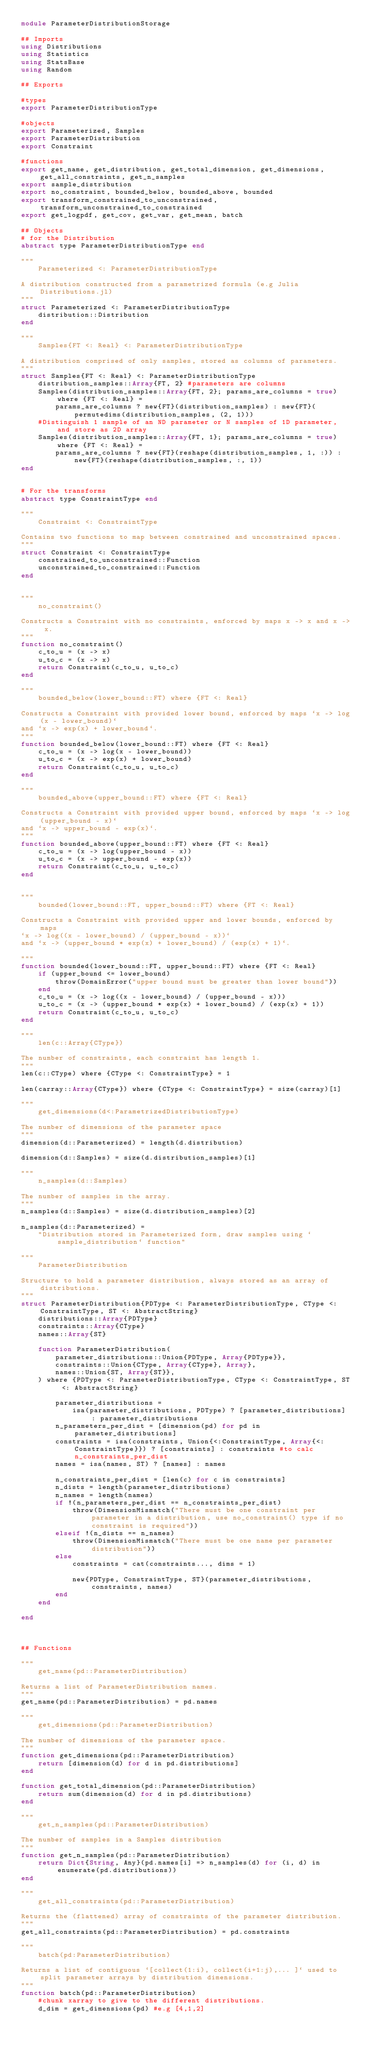Convert code to text. <code><loc_0><loc_0><loc_500><loc_500><_Julia_>module ParameterDistributionStorage

## Imports
using Distributions
using Statistics
using StatsBase
using Random

## Exports

#types
export ParameterDistributionType

#objects
export Parameterized, Samples
export ParameterDistribution
export Constraint

#functions
export get_name, get_distribution, get_total_dimension, get_dimensions, get_all_constraints, get_n_samples
export sample_distribution
export no_constraint, bounded_below, bounded_above, bounded
export transform_constrained_to_unconstrained, transform_unconstrained_to_constrained
export get_logpdf, get_cov, get_var, get_mean, batch

## Objects
# for the Distribution
abstract type ParameterDistributionType end

"""
    Parameterized <: ParameterDistributionType
    
A distribution constructed from a parametrized formula (e.g Julia Distributions.jl)
"""
struct Parameterized <: ParameterDistributionType
    distribution::Distribution
end

"""
    Samples{FT <: Real} <: ParameterDistributionType

A distribution comprised of only samples, stored as columns of parameters.
"""
struct Samples{FT <: Real} <: ParameterDistributionType
    distribution_samples::Array{FT, 2} #parameters are columns
    Samples(distribution_samples::Array{FT, 2}; params_are_columns = true) where {FT <: Real} =
        params_are_columns ? new{FT}(distribution_samples) : new{FT}(permutedims(distribution_samples, (2, 1)))
    #Distinguish 1 sample of an ND parameter or N samples of 1D parameter, and store as 2D array  
    Samples(distribution_samples::Array{FT, 1}; params_are_columns = true) where {FT <: Real} =
        params_are_columns ? new{FT}(reshape(distribution_samples, 1, :)) : new{FT}(reshape(distribution_samples, :, 1))
end


# For the transforms
abstract type ConstraintType end

"""
    Constraint <: ConstraintType

Contains two functions to map between constrained and unconstrained spaces.
"""
struct Constraint <: ConstraintType
    constrained_to_unconstrained::Function
    unconstrained_to_constrained::Function
end


"""
    no_constraint()

Constructs a Constraint with no constraints, enforced by maps x -> x and x -> x.
"""
function no_constraint()
    c_to_u = (x -> x)
    u_to_c = (x -> x)
    return Constraint(c_to_u, u_to_c)
end

"""
    bounded_below(lower_bound::FT) where {FT <: Real}

Constructs a Constraint with provided lower bound, enforced by maps `x -> log(x - lower_bound)`
and `x -> exp(x) + lower_bound`.
"""
function bounded_below(lower_bound::FT) where {FT <: Real}
    c_to_u = (x -> log(x - lower_bound))
    u_to_c = (x -> exp(x) + lower_bound)
    return Constraint(c_to_u, u_to_c)
end

"""
    bounded_above(upper_bound::FT) where {FT <: Real} 

Constructs a Constraint with provided upper bound, enforced by maps `x -> log(upper_bound - x)`
and `x -> upper_bound - exp(x)`.
"""
function bounded_above(upper_bound::FT) where {FT <: Real}
    c_to_u = (x -> log(upper_bound - x))
    u_to_c = (x -> upper_bound - exp(x))
    return Constraint(c_to_u, u_to_c)
end


"""
    bounded(lower_bound::FT, upper_bound::FT) where {FT <: Real} 

Constructs a Constraint with provided upper and lower bounds, enforced by maps
`x -> log((x - lower_bound) / (upper_bound - x))`
and `x -> (upper_bound * exp(x) + lower_bound) / (exp(x) + 1)`.

"""
function bounded(lower_bound::FT, upper_bound::FT) where {FT <: Real}
    if (upper_bound <= lower_bound)
        throw(DomainError("upper bound must be greater than lower bound"))
    end
    c_to_u = (x -> log((x - lower_bound) / (upper_bound - x)))
    u_to_c = (x -> (upper_bound * exp(x) + lower_bound) / (exp(x) + 1))
    return Constraint(c_to_u, u_to_c)
end

"""
    len(c::Array{CType})

The number of constraints, each constraint has length 1.
"""
len(c::CType) where {CType <: ConstraintType} = 1

len(carray::Array{CType}) where {CType <: ConstraintType} = size(carray)[1]

"""
    get_dimensions(d<:ParametrizedDistributionType)

The number of dimensions of the parameter space
"""
dimension(d::Parameterized) = length(d.distribution)

dimension(d::Samples) = size(d.distribution_samples)[1]

"""
    n_samples(d::Samples)

The number of samples in the array.
"""
n_samples(d::Samples) = size(d.distribution_samples)[2]

n_samples(d::Parameterized) =
    "Distribution stored in Parameterized form, draw samples using `sample_distribution` function"

"""
    ParameterDistribution

Structure to hold a parameter distribution, always stored as an array of distributions.
"""
struct ParameterDistribution{PDType <: ParameterDistributionType, CType <: ConstraintType, ST <: AbstractString}
    distributions::Array{PDType}
    constraints::Array{CType}
    names::Array{ST}

    function ParameterDistribution(
        parameter_distributions::Union{PDType, Array{PDType}},
        constraints::Union{CType, Array{CType}, Array},
        names::Union{ST, Array{ST}},
    ) where {PDType <: ParameterDistributionType, CType <: ConstraintType, ST <: AbstractString}

        parameter_distributions =
            isa(parameter_distributions, PDType) ? [parameter_distributions] : parameter_distributions
        n_parameters_per_dist = [dimension(pd) for pd in parameter_distributions]
        constraints = isa(constraints, Union{<:ConstraintType, Array{<:ConstraintType}}) ? [constraints] : constraints #to calc n_constraints_per_dist
        names = isa(names, ST) ? [names] : names

        n_constraints_per_dist = [len(c) for c in constraints]
        n_dists = length(parameter_distributions)
        n_names = length(names)
        if !(n_parameters_per_dist == n_constraints_per_dist)
            throw(DimensionMismatch("There must be one constraint per parameter in a distribution, use no_constraint() type if no constraint is required"))
        elseif !(n_dists == n_names)
            throw(DimensionMismatch("There must be one name per parameter distribution"))
        else
            constraints = cat(constraints..., dims = 1)

            new{PDType, ConstraintType, ST}(parameter_distributions, constraints, names)
        end
    end

end



## Functions

"""
    get_name(pd::ParameterDistribution)

Returns a list of ParameterDistribution names.
"""
get_name(pd::ParameterDistribution) = pd.names

"""
    get_dimensions(pd::ParameterDistribution)

The number of dimensions of the parameter space.
"""
function get_dimensions(pd::ParameterDistribution)
    return [dimension(d) for d in pd.distributions]
end

function get_total_dimension(pd::ParameterDistribution)
    return sum(dimension(d) for d in pd.distributions)
end

"""
    get_n_samples(pd::ParameterDistribution)

The number of samples in a Samples distribution
"""
function get_n_samples(pd::ParameterDistribution)
    return Dict{String, Any}(pd.names[i] => n_samples(d) for (i, d) in enumerate(pd.distributions))
end

"""
    get_all_constraints(pd::ParameterDistribution)

Returns the (flattened) array of constraints of the parameter distribution.
"""
get_all_constraints(pd::ParameterDistribution) = pd.constraints

"""
    batch(pd:ParameterDistribution)

Returns a list of contiguous `[collect(1:i), collect(i+1:j),... ]` used to split parameter arrays by distribution dimensions.
"""
function batch(pd::ParameterDistribution)
    #chunk xarray to give to the different distributions.
    d_dim = get_dimensions(pd) #e.g [4,1,2]</code> 